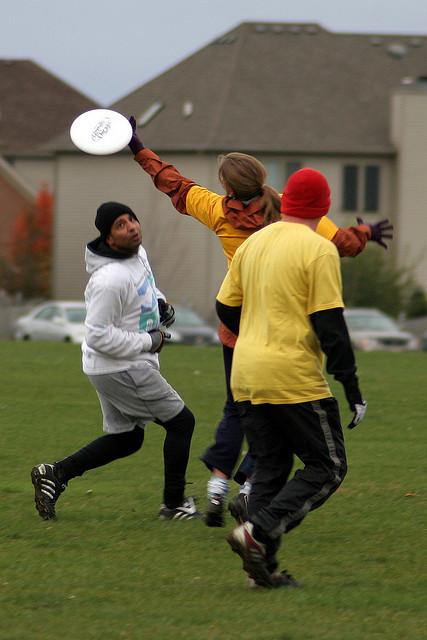What is the girl catching?
Write a very short answer. Frisbee. What sport is this?
Write a very short answer. Frisbee. What is the man running to?
Concise answer only. Frisbee. Is there a trashcan near the players?
Be succinct. No. What are the black gloves used for?
Keep it brief. Catching. How many  people are playing?
Keep it brief. 3. Where is the Frisbee?
Concise answer only. In air. 